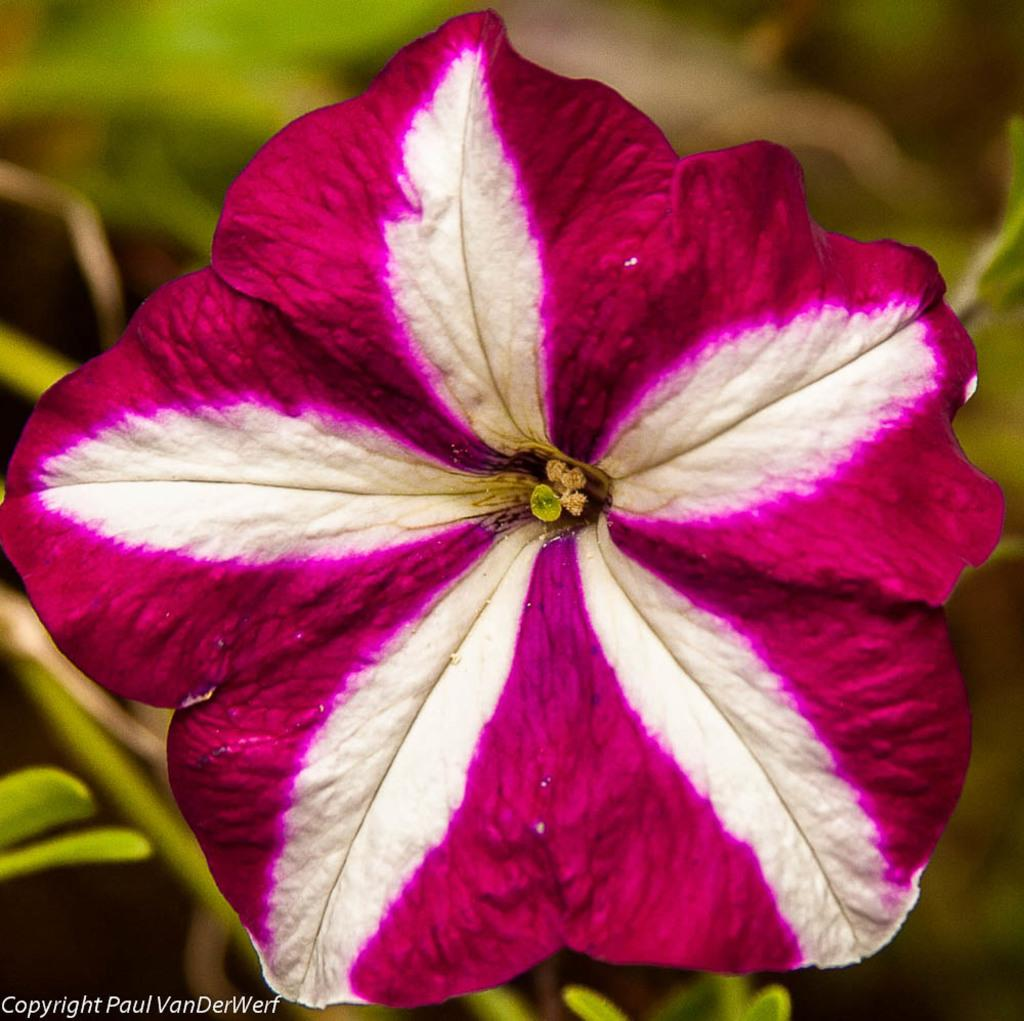What is the main subject in the foreground of the image? There is a flower in the foreground of the image. How would you describe the background of the image? The background of the image is blurry. Is there any text present in the image? Yes, there is text at the bottom of the image. Can you see any homes or tramps in the image? No, there are no homes or tramps present in the image. Are there any stockings visible in the image? No, there are no stockings visible in the image. 